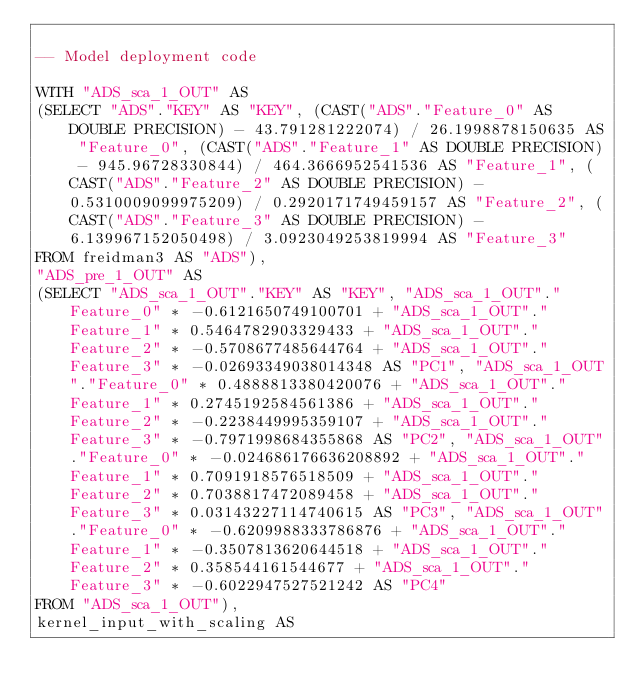<code> <loc_0><loc_0><loc_500><loc_500><_SQL_>
-- Model deployment code

WITH "ADS_sca_1_OUT" AS 
(SELECT "ADS"."KEY" AS "KEY", (CAST("ADS"."Feature_0" AS DOUBLE PRECISION) - 43.791281222074) / 26.1998878150635 AS "Feature_0", (CAST("ADS"."Feature_1" AS DOUBLE PRECISION) - 945.96728330844) / 464.3666952541536 AS "Feature_1", (CAST("ADS"."Feature_2" AS DOUBLE PRECISION) - 0.5310009099975209) / 0.2920171749459157 AS "Feature_2", (CAST("ADS"."Feature_3" AS DOUBLE PRECISION) - 6.139967152050498) / 3.0923049253819994 AS "Feature_3" 
FROM freidman3 AS "ADS"), 
"ADS_pre_1_OUT" AS 
(SELECT "ADS_sca_1_OUT"."KEY" AS "KEY", "ADS_sca_1_OUT"."Feature_0" * -0.6121650749100701 + "ADS_sca_1_OUT"."Feature_1" * 0.5464782903329433 + "ADS_sca_1_OUT"."Feature_2" * -0.5708677485644764 + "ADS_sca_1_OUT"."Feature_3" * -0.02693349038014348 AS "PC1", "ADS_sca_1_OUT"."Feature_0" * 0.4888813380420076 + "ADS_sca_1_OUT"."Feature_1" * 0.2745192584561386 + "ADS_sca_1_OUT"."Feature_2" * -0.2238449995359107 + "ADS_sca_1_OUT"."Feature_3" * -0.7971998684355868 AS "PC2", "ADS_sca_1_OUT"."Feature_0" * -0.024686176636208892 + "ADS_sca_1_OUT"."Feature_1" * 0.7091918576518509 + "ADS_sca_1_OUT"."Feature_2" * 0.7038817472089458 + "ADS_sca_1_OUT"."Feature_3" * 0.03143227114740615 AS "PC3", "ADS_sca_1_OUT"."Feature_0" * -0.6209988333786876 + "ADS_sca_1_OUT"."Feature_1" * -0.3507813620644518 + "ADS_sca_1_OUT"."Feature_2" * 0.358544161544677 + "ADS_sca_1_OUT"."Feature_3" * -0.6022947527521242 AS "PC4" 
FROM "ADS_sca_1_OUT"), 
kernel_input_with_scaling AS </code> 